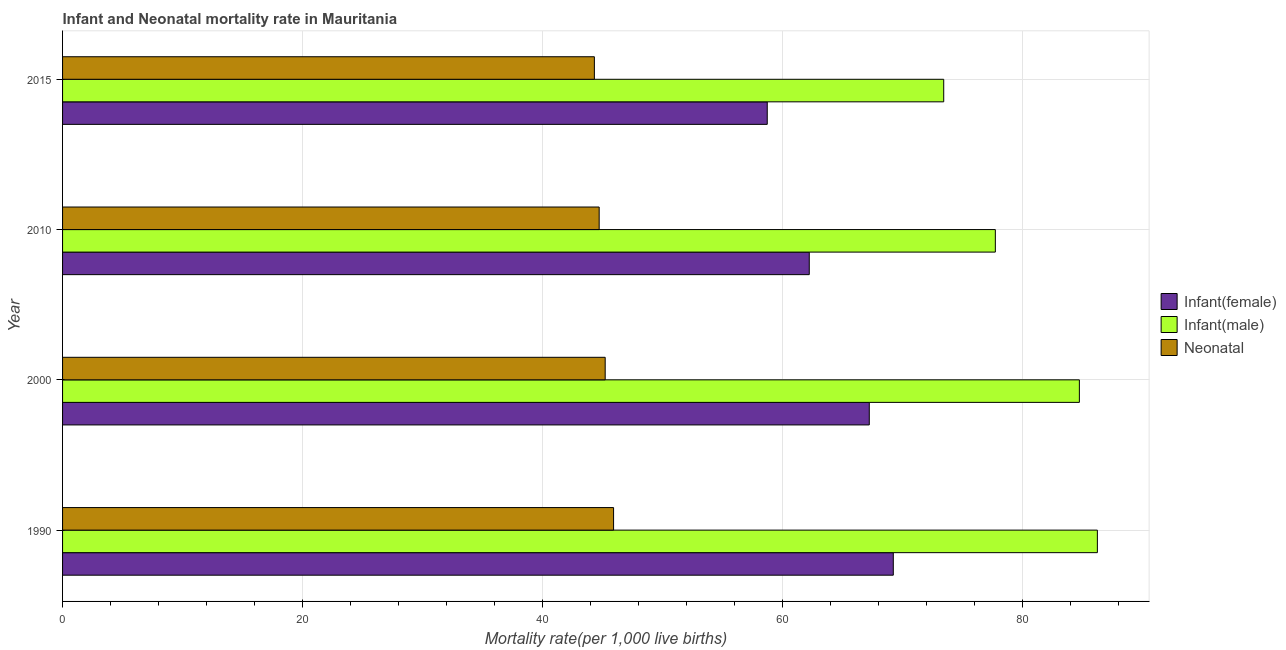How many groups of bars are there?
Your answer should be compact. 4. Are the number of bars per tick equal to the number of legend labels?
Your response must be concise. Yes. Are the number of bars on each tick of the Y-axis equal?
Ensure brevity in your answer.  Yes. How many bars are there on the 3rd tick from the top?
Your response must be concise. 3. How many bars are there on the 2nd tick from the bottom?
Provide a short and direct response. 3. What is the label of the 3rd group of bars from the top?
Provide a short and direct response. 2000. In how many cases, is the number of bars for a given year not equal to the number of legend labels?
Give a very brief answer. 0. What is the infant mortality rate(male) in 2015?
Ensure brevity in your answer.  73.4. Across all years, what is the maximum neonatal mortality rate?
Keep it short and to the point. 45.9. Across all years, what is the minimum infant mortality rate(female)?
Keep it short and to the point. 58.7. In which year was the neonatal mortality rate minimum?
Ensure brevity in your answer.  2015. What is the total infant mortality rate(male) in the graph?
Provide a short and direct response. 322. What is the difference between the infant mortality rate(male) in 2000 and that in 2015?
Your response must be concise. 11.3. What is the difference between the infant mortality rate(female) in 1990 and the infant mortality rate(male) in 2015?
Provide a short and direct response. -4.2. What is the average neonatal mortality rate per year?
Keep it short and to the point. 45.02. In how many years, is the infant mortality rate(female) greater than 36 ?
Offer a very short reply. 4. What is the ratio of the infant mortality rate(male) in 2010 to that in 2015?
Provide a short and direct response. 1.06. Is the infant mortality rate(female) in 1990 less than that in 2015?
Make the answer very short. No. What is the difference between the highest and the lowest neonatal mortality rate?
Give a very brief answer. 1.6. In how many years, is the neonatal mortality rate greater than the average neonatal mortality rate taken over all years?
Your response must be concise. 2. What does the 3rd bar from the top in 1990 represents?
Your answer should be very brief. Infant(female). What does the 3rd bar from the bottom in 2010 represents?
Your response must be concise. Neonatal . Is it the case that in every year, the sum of the infant mortality rate(female) and infant mortality rate(male) is greater than the neonatal mortality rate?
Offer a terse response. Yes. How many bars are there?
Your answer should be very brief. 12. Are all the bars in the graph horizontal?
Provide a short and direct response. Yes. Are the values on the major ticks of X-axis written in scientific E-notation?
Your answer should be compact. No. Does the graph contain any zero values?
Your answer should be very brief. No. Where does the legend appear in the graph?
Your answer should be very brief. Center right. What is the title of the graph?
Give a very brief answer. Infant and Neonatal mortality rate in Mauritania. What is the label or title of the X-axis?
Ensure brevity in your answer.  Mortality rate(per 1,0 live births). What is the label or title of the Y-axis?
Provide a succinct answer. Year. What is the Mortality rate(per 1,000 live births) in Infant(female) in 1990?
Offer a very short reply. 69.2. What is the Mortality rate(per 1,000 live births) of Infant(male) in 1990?
Make the answer very short. 86.2. What is the Mortality rate(per 1,000 live births) in Neonatal  in 1990?
Offer a terse response. 45.9. What is the Mortality rate(per 1,000 live births) of Infant(female) in 2000?
Your response must be concise. 67.2. What is the Mortality rate(per 1,000 live births) of Infant(male) in 2000?
Your answer should be very brief. 84.7. What is the Mortality rate(per 1,000 live births) in Neonatal  in 2000?
Make the answer very short. 45.2. What is the Mortality rate(per 1,000 live births) in Infant(female) in 2010?
Your answer should be very brief. 62.2. What is the Mortality rate(per 1,000 live births) in Infant(male) in 2010?
Give a very brief answer. 77.7. What is the Mortality rate(per 1,000 live births) in Neonatal  in 2010?
Give a very brief answer. 44.7. What is the Mortality rate(per 1,000 live births) of Infant(female) in 2015?
Make the answer very short. 58.7. What is the Mortality rate(per 1,000 live births) of Infant(male) in 2015?
Keep it short and to the point. 73.4. What is the Mortality rate(per 1,000 live births) in Neonatal  in 2015?
Offer a terse response. 44.3. Across all years, what is the maximum Mortality rate(per 1,000 live births) in Infant(female)?
Your answer should be compact. 69.2. Across all years, what is the maximum Mortality rate(per 1,000 live births) of Infant(male)?
Keep it short and to the point. 86.2. Across all years, what is the maximum Mortality rate(per 1,000 live births) of Neonatal ?
Your answer should be very brief. 45.9. Across all years, what is the minimum Mortality rate(per 1,000 live births) of Infant(female)?
Your answer should be compact. 58.7. Across all years, what is the minimum Mortality rate(per 1,000 live births) of Infant(male)?
Make the answer very short. 73.4. Across all years, what is the minimum Mortality rate(per 1,000 live births) of Neonatal ?
Your answer should be very brief. 44.3. What is the total Mortality rate(per 1,000 live births) in Infant(female) in the graph?
Provide a succinct answer. 257.3. What is the total Mortality rate(per 1,000 live births) in Infant(male) in the graph?
Provide a short and direct response. 322. What is the total Mortality rate(per 1,000 live births) of Neonatal  in the graph?
Offer a very short reply. 180.1. What is the difference between the Mortality rate(per 1,000 live births) in Infant(male) in 1990 and that in 2010?
Keep it short and to the point. 8.5. What is the difference between the Mortality rate(per 1,000 live births) in Neonatal  in 1990 and that in 2010?
Give a very brief answer. 1.2. What is the difference between the Mortality rate(per 1,000 live births) in Neonatal  in 1990 and that in 2015?
Offer a terse response. 1.6. What is the difference between the Mortality rate(per 1,000 live births) in Infant(female) in 2000 and that in 2010?
Your answer should be very brief. 5. What is the difference between the Mortality rate(per 1,000 live births) in Neonatal  in 2000 and that in 2010?
Provide a short and direct response. 0.5. What is the difference between the Mortality rate(per 1,000 live births) of Infant(male) in 2000 and that in 2015?
Offer a terse response. 11.3. What is the difference between the Mortality rate(per 1,000 live births) in Infant(female) in 2010 and that in 2015?
Your answer should be compact. 3.5. What is the difference between the Mortality rate(per 1,000 live births) in Infant(female) in 1990 and the Mortality rate(per 1,000 live births) in Infant(male) in 2000?
Provide a succinct answer. -15.5. What is the difference between the Mortality rate(per 1,000 live births) in Infant(female) in 1990 and the Mortality rate(per 1,000 live births) in Neonatal  in 2000?
Provide a short and direct response. 24. What is the difference between the Mortality rate(per 1,000 live births) in Infant(male) in 1990 and the Mortality rate(per 1,000 live births) in Neonatal  in 2010?
Keep it short and to the point. 41.5. What is the difference between the Mortality rate(per 1,000 live births) of Infant(female) in 1990 and the Mortality rate(per 1,000 live births) of Neonatal  in 2015?
Your answer should be very brief. 24.9. What is the difference between the Mortality rate(per 1,000 live births) in Infant(male) in 1990 and the Mortality rate(per 1,000 live births) in Neonatal  in 2015?
Provide a succinct answer. 41.9. What is the difference between the Mortality rate(per 1,000 live births) in Infant(female) in 2000 and the Mortality rate(per 1,000 live births) in Infant(male) in 2010?
Your answer should be very brief. -10.5. What is the difference between the Mortality rate(per 1,000 live births) in Infant(male) in 2000 and the Mortality rate(per 1,000 live births) in Neonatal  in 2010?
Your answer should be very brief. 40. What is the difference between the Mortality rate(per 1,000 live births) of Infant(female) in 2000 and the Mortality rate(per 1,000 live births) of Infant(male) in 2015?
Offer a very short reply. -6.2. What is the difference between the Mortality rate(per 1,000 live births) in Infant(female) in 2000 and the Mortality rate(per 1,000 live births) in Neonatal  in 2015?
Your answer should be very brief. 22.9. What is the difference between the Mortality rate(per 1,000 live births) of Infant(male) in 2000 and the Mortality rate(per 1,000 live births) of Neonatal  in 2015?
Your answer should be compact. 40.4. What is the difference between the Mortality rate(per 1,000 live births) in Infant(female) in 2010 and the Mortality rate(per 1,000 live births) in Infant(male) in 2015?
Keep it short and to the point. -11.2. What is the difference between the Mortality rate(per 1,000 live births) of Infant(female) in 2010 and the Mortality rate(per 1,000 live births) of Neonatal  in 2015?
Offer a terse response. 17.9. What is the difference between the Mortality rate(per 1,000 live births) of Infant(male) in 2010 and the Mortality rate(per 1,000 live births) of Neonatal  in 2015?
Your answer should be very brief. 33.4. What is the average Mortality rate(per 1,000 live births) of Infant(female) per year?
Your response must be concise. 64.33. What is the average Mortality rate(per 1,000 live births) in Infant(male) per year?
Offer a very short reply. 80.5. What is the average Mortality rate(per 1,000 live births) of Neonatal  per year?
Your answer should be very brief. 45.02. In the year 1990, what is the difference between the Mortality rate(per 1,000 live births) in Infant(female) and Mortality rate(per 1,000 live births) in Neonatal ?
Keep it short and to the point. 23.3. In the year 1990, what is the difference between the Mortality rate(per 1,000 live births) in Infant(male) and Mortality rate(per 1,000 live births) in Neonatal ?
Offer a very short reply. 40.3. In the year 2000, what is the difference between the Mortality rate(per 1,000 live births) of Infant(female) and Mortality rate(per 1,000 live births) of Infant(male)?
Keep it short and to the point. -17.5. In the year 2000, what is the difference between the Mortality rate(per 1,000 live births) in Infant(female) and Mortality rate(per 1,000 live births) in Neonatal ?
Provide a short and direct response. 22. In the year 2000, what is the difference between the Mortality rate(per 1,000 live births) in Infant(male) and Mortality rate(per 1,000 live births) in Neonatal ?
Provide a short and direct response. 39.5. In the year 2010, what is the difference between the Mortality rate(per 1,000 live births) in Infant(female) and Mortality rate(per 1,000 live births) in Infant(male)?
Offer a very short reply. -15.5. In the year 2010, what is the difference between the Mortality rate(per 1,000 live births) of Infant(female) and Mortality rate(per 1,000 live births) of Neonatal ?
Your answer should be very brief. 17.5. In the year 2015, what is the difference between the Mortality rate(per 1,000 live births) of Infant(female) and Mortality rate(per 1,000 live births) of Infant(male)?
Provide a short and direct response. -14.7. In the year 2015, what is the difference between the Mortality rate(per 1,000 live births) of Infant(male) and Mortality rate(per 1,000 live births) of Neonatal ?
Your answer should be compact. 29.1. What is the ratio of the Mortality rate(per 1,000 live births) of Infant(female) in 1990 to that in 2000?
Make the answer very short. 1.03. What is the ratio of the Mortality rate(per 1,000 live births) in Infant(male) in 1990 to that in 2000?
Your response must be concise. 1.02. What is the ratio of the Mortality rate(per 1,000 live births) in Neonatal  in 1990 to that in 2000?
Your response must be concise. 1.02. What is the ratio of the Mortality rate(per 1,000 live births) in Infant(female) in 1990 to that in 2010?
Your answer should be very brief. 1.11. What is the ratio of the Mortality rate(per 1,000 live births) in Infant(male) in 1990 to that in 2010?
Provide a succinct answer. 1.11. What is the ratio of the Mortality rate(per 1,000 live births) of Neonatal  in 1990 to that in 2010?
Offer a very short reply. 1.03. What is the ratio of the Mortality rate(per 1,000 live births) in Infant(female) in 1990 to that in 2015?
Provide a short and direct response. 1.18. What is the ratio of the Mortality rate(per 1,000 live births) of Infant(male) in 1990 to that in 2015?
Your answer should be compact. 1.17. What is the ratio of the Mortality rate(per 1,000 live births) of Neonatal  in 1990 to that in 2015?
Provide a short and direct response. 1.04. What is the ratio of the Mortality rate(per 1,000 live births) of Infant(female) in 2000 to that in 2010?
Offer a very short reply. 1.08. What is the ratio of the Mortality rate(per 1,000 live births) of Infant(male) in 2000 to that in 2010?
Ensure brevity in your answer.  1.09. What is the ratio of the Mortality rate(per 1,000 live births) of Neonatal  in 2000 to that in 2010?
Your answer should be very brief. 1.01. What is the ratio of the Mortality rate(per 1,000 live births) in Infant(female) in 2000 to that in 2015?
Your answer should be very brief. 1.14. What is the ratio of the Mortality rate(per 1,000 live births) of Infant(male) in 2000 to that in 2015?
Offer a terse response. 1.15. What is the ratio of the Mortality rate(per 1,000 live births) in Neonatal  in 2000 to that in 2015?
Ensure brevity in your answer.  1.02. What is the ratio of the Mortality rate(per 1,000 live births) of Infant(female) in 2010 to that in 2015?
Your answer should be very brief. 1.06. What is the ratio of the Mortality rate(per 1,000 live births) in Infant(male) in 2010 to that in 2015?
Give a very brief answer. 1.06. What is the difference between the highest and the second highest Mortality rate(per 1,000 live births) in Infant(female)?
Ensure brevity in your answer.  2. 